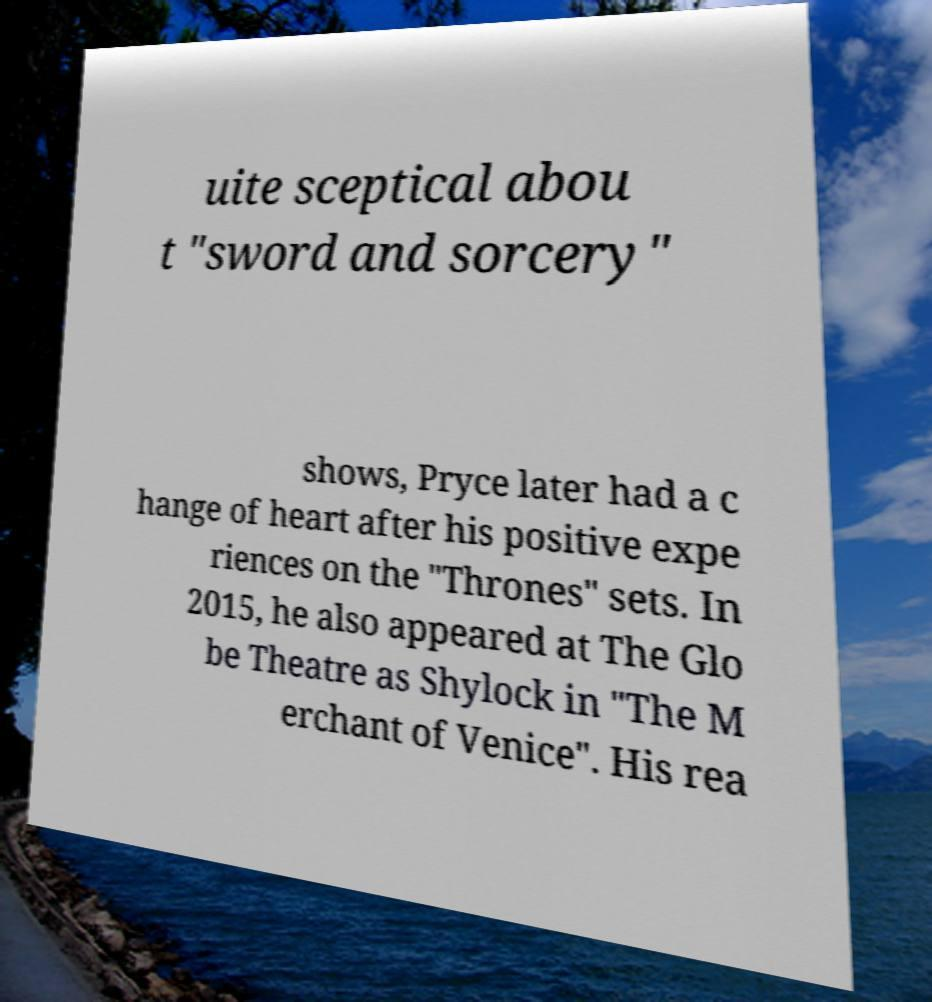Can you accurately transcribe the text from the provided image for me? uite sceptical abou t "sword and sorcery" shows, Pryce later had a c hange of heart after his positive expe riences on the "Thrones" sets. In 2015, he also appeared at The Glo be Theatre as Shylock in "The M erchant of Venice". His rea 